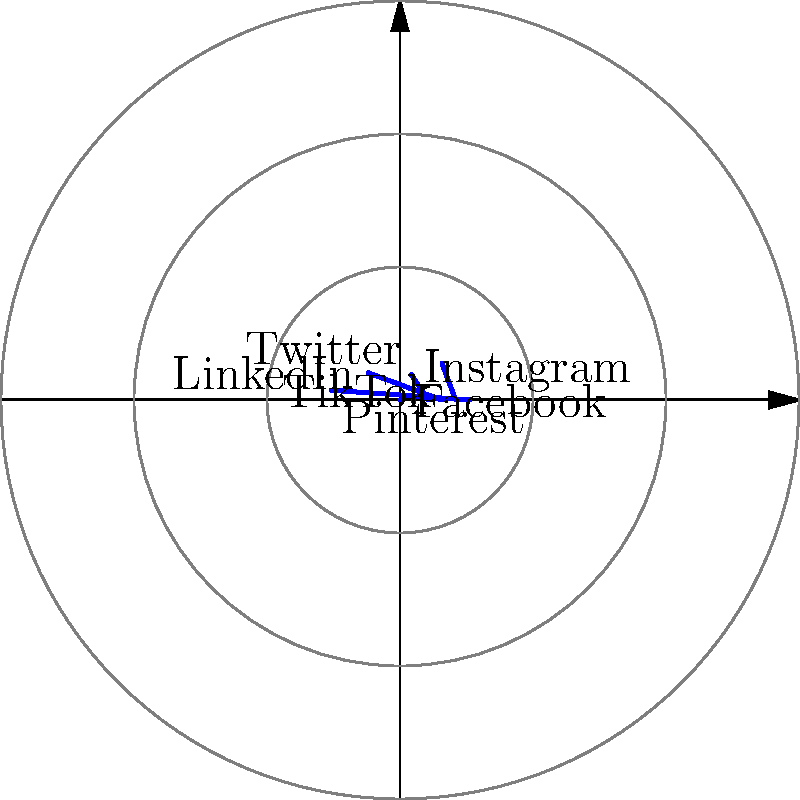In the polar coordinate system shown, social media platforms' market shares are represented. If you were to focus your digital marketing efforts on the top three platforms, what percentage of the total market share would you be targeting? To solve this problem, we need to follow these steps:

1. Identify the top three platforms by market share:
   - Facebook: 30%
   - Instagram: 25%
   - Twitter: 20%

2. Sum up the market shares of these top three platforms:
   $30\% + 25\% + 20\% = 75\%$

3. Calculate the total market share represented in the diagram:
   $30\% + 25\% + 20\% + 15\% + 7\% + 3\% = 100\%$

4. Calculate the percentage of the total market share that the top three platforms represent:
   $\frac{75\%}{100\%} \times 100 = 75\%$

Therefore, by focusing on the top three platforms (Facebook, Instagram, and Twitter), you would be targeting 75% of the total market share represented in this polar coordinate system.
Answer: 75% 